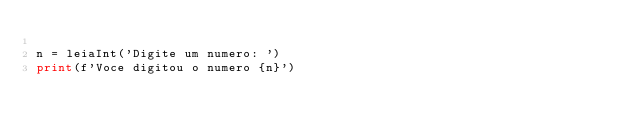Convert code to text. <code><loc_0><loc_0><loc_500><loc_500><_Python_>
n = leiaInt('Digite um numero: ')
print(f'Voce digitou o numero {n}')</code> 